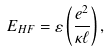Convert formula to latex. <formula><loc_0><loc_0><loc_500><loc_500>E _ { H F } = \varepsilon \left ( \frac { e ^ { 2 } } { \kappa \ell } \right ) ,</formula> 